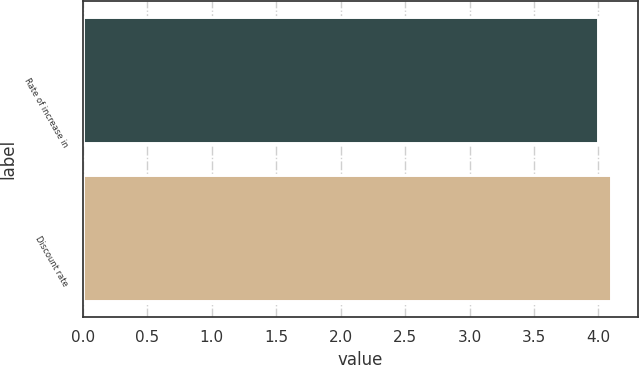Convert chart. <chart><loc_0><loc_0><loc_500><loc_500><bar_chart><fcel>Rate of increase in<fcel>Discount rate<nl><fcel>4<fcel>4.1<nl></chart> 